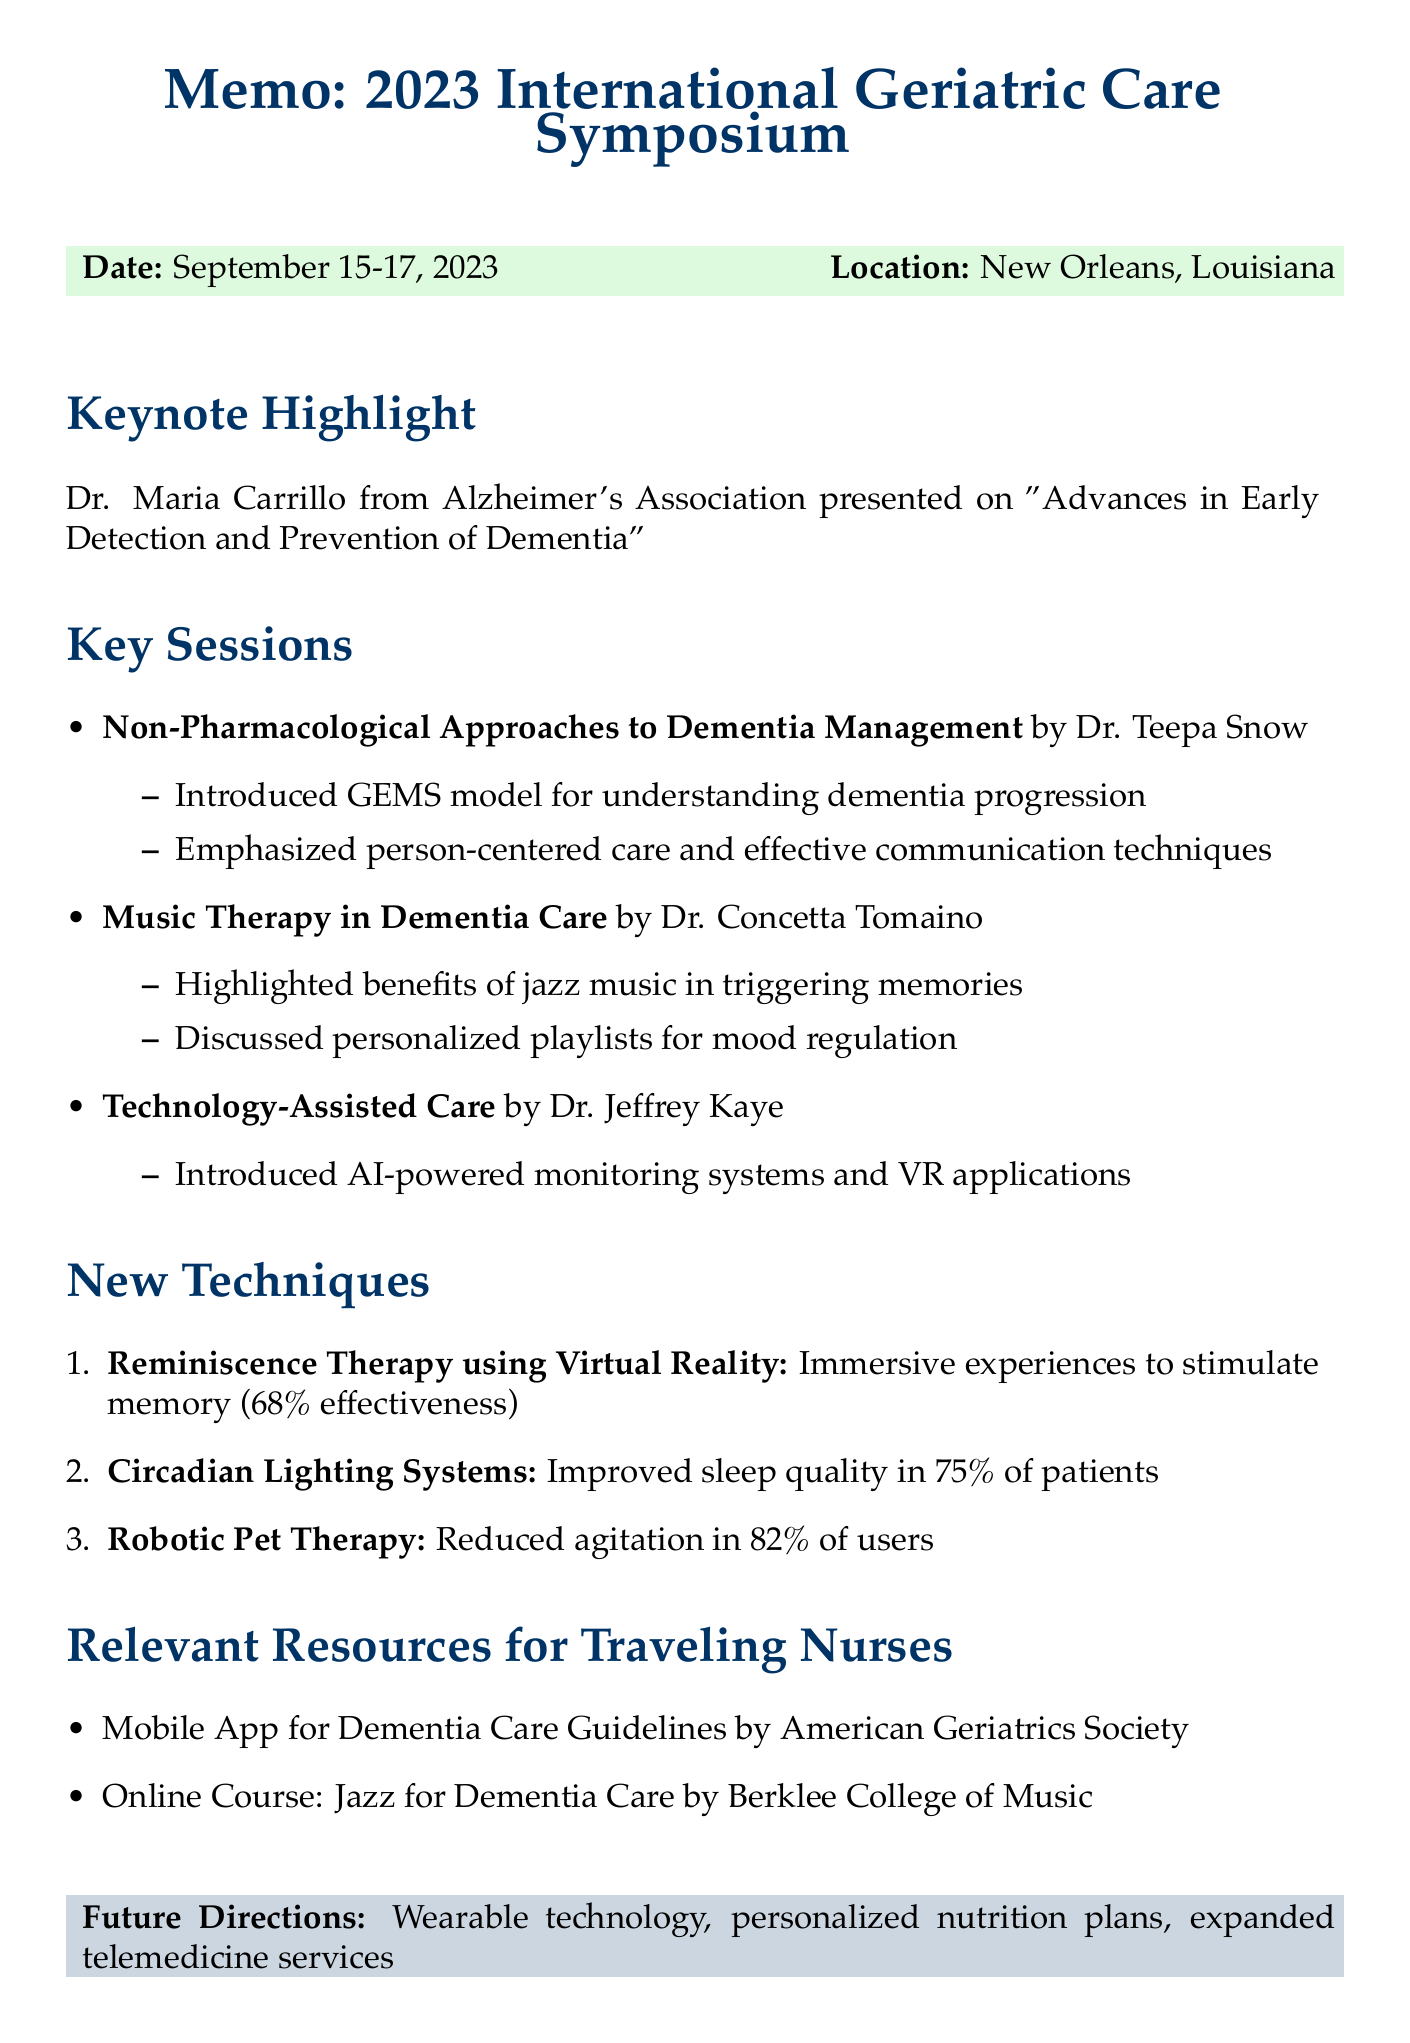What is the location of the conference? The document specifies that the conference took place in New Orleans, Louisiana.
Answer: New Orleans, Louisiana Who was the keynote speaker? The document lists Dr. Maria Carrillo as the keynote speaker.
Answer: Dr. Maria Carrillo What is the effectiveness percentage of Reminiscence Therapy using Virtual Reality? The document states that Reminiscence Therapy using Virtual Reality showed effectiveness in 68% of participants.
Answer: 68% Which technique improved sleep quality in 75% of dementia patients? According to the document, Circadian Lighting Systems improved sleep quality in 75% of dementia patients.
Answer: Circadian Lighting Systems What type of therapy is discussed by Dr. Concetta Tomaino? The document mentions Music Therapy in Dementia Care as discussed by Dr. Concetta Tomaino.
Answer: Music Therapy What feature does the Mobile App for Dementia Care Guidelines provide? The document states that the mobile app offers a quick reference for evidence-based interventions.
Answer: Quick reference for evidence-based interventions What session is related to technology in dementia management? The document lists Technology-Assisted Care for Dementia Patients as a highlighted session.
Answer: Technology-Assisted Care What is one future direction mentioned in the memo? The document outlines future directions including the integration of wearable technology.
Answer: Integration of wearable technology 